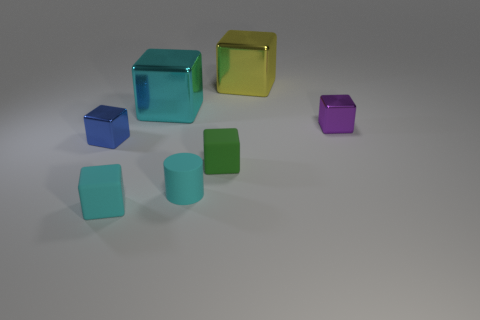The image seems quite minimalist. What might be the purpose of this scene? Given the simplicity and the arrangement of the objects, the scene might have been created with a focus on visual aesthetics, perhaps meant for a background, a 3D modeling showcase, or as a part of a study in color and form. It's a clean and balanced composition that highlights the shapes and the interplay of light and color. 